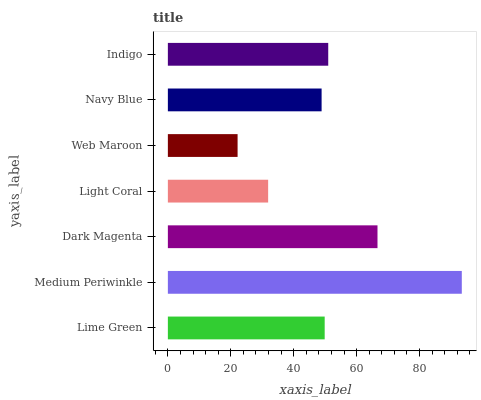Is Web Maroon the minimum?
Answer yes or no. Yes. Is Medium Periwinkle the maximum?
Answer yes or no. Yes. Is Dark Magenta the minimum?
Answer yes or no. No. Is Dark Magenta the maximum?
Answer yes or no. No. Is Medium Periwinkle greater than Dark Magenta?
Answer yes or no. Yes. Is Dark Magenta less than Medium Periwinkle?
Answer yes or no. Yes. Is Dark Magenta greater than Medium Periwinkle?
Answer yes or no. No. Is Medium Periwinkle less than Dark Magenta?
Answer yes or no. No. Is Lime Green the high median?
Answer yes or no. Yes. Is Lime Green the low median?
Answer yes or no. Yes. Is Navy Blue the high median?
Answer yes or no. No. Is Web Maroon the low median?
Answer yes or no. No. 